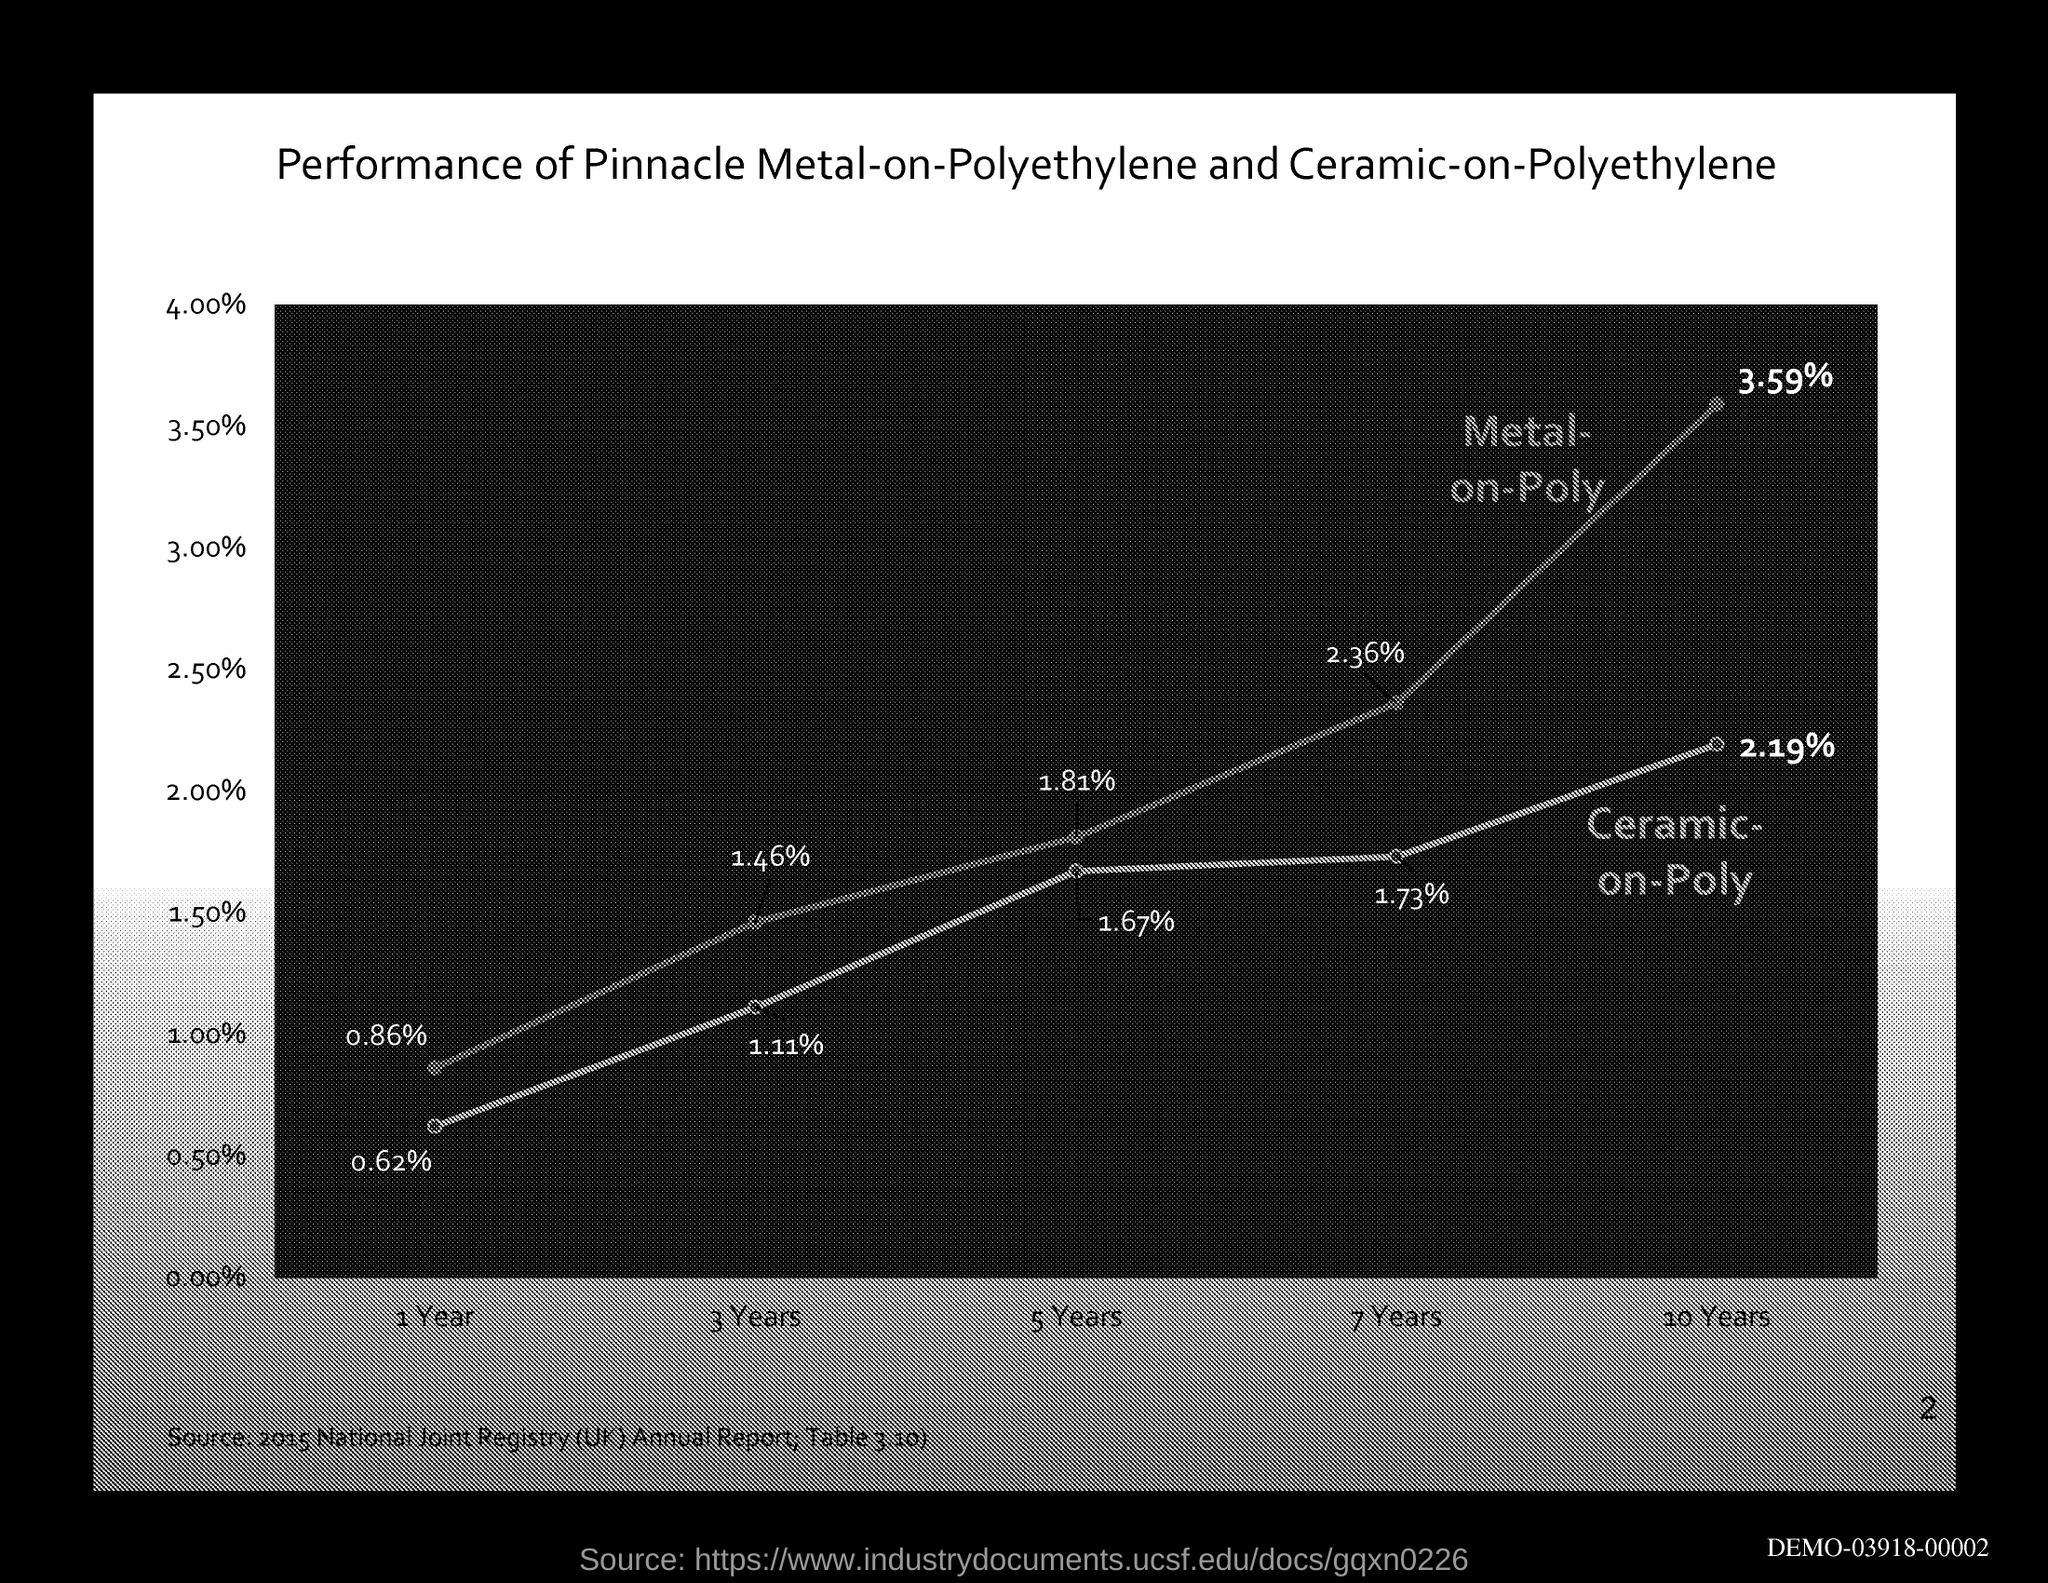Mention a couple of crucial points in this snapshot. The title of the graph represents the performance of Pinnacle metal-on-polyethylene and ceramic-on-polyethylene hip replacements in comparison to traditional hip replacements. 